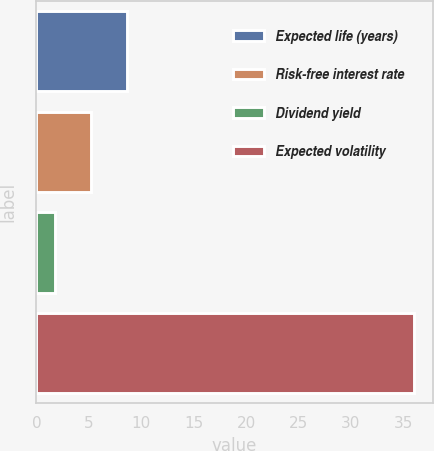<chart> <loc_0><loc_0><loc_500><loc_500><bar_chart><fcel>Expected life (years)<fcel>Risk-free interest rate<fcel>Dividend yield<fcel>Expected volatility<nl><fcel>8.64<fcel>5.22<fcel>1.8<fcel>36<nl></chart> 